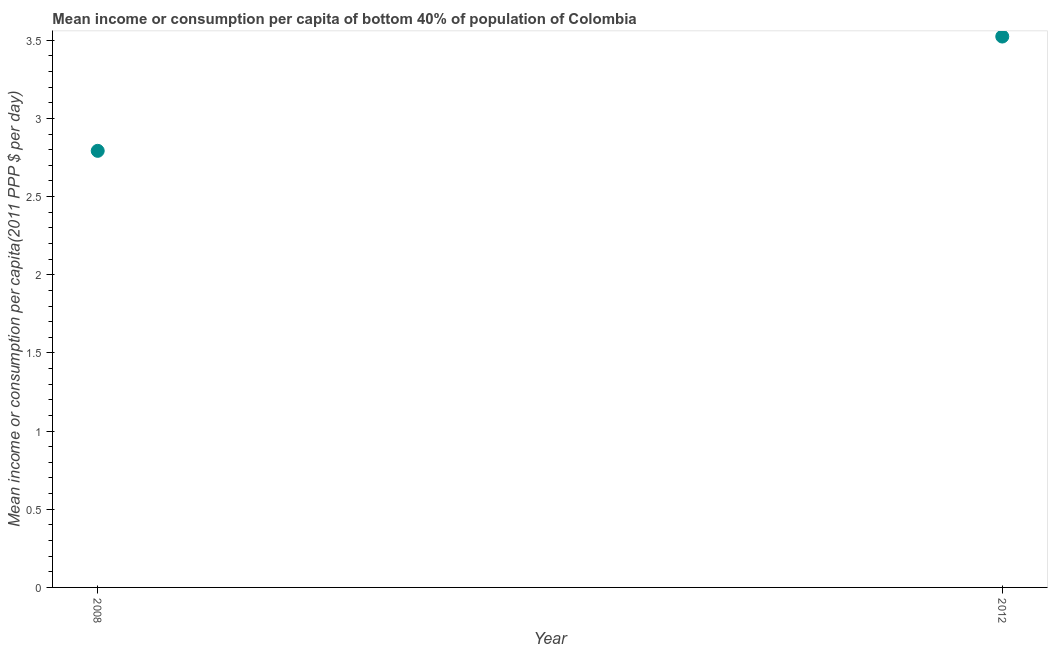What is the mean income or consumption in 2008?
Keep it short and to the point. 2.79. Across all years, what is the maximum mean income or consumption?
Make the answer very short. 3.52. Across all years, what is the minimum mean income or consumption?
Your response must be concise. 2.79. In which year was the mean income or consumption minimum?
Give a very brief answer. 2008. What is the sum of the mean income or consumption?
Your response must be concise. 6.32. What is the difference between the mean income or consumption in 2008 and 2012?
Your answer should be very brief. -0.73. What is the average mean income or consumption per year?
Provide a short and direct response. 3.16. What is the median mean income or consumption?
Keep it short and to the point. 3.16. In how many years, is the mean income or consumption greater than 3.3 $?
Provide a succinct answer. 1. What is the ratio of the mean income or consumption in 2008 to that in 2012?
Ensure brevity in your answer.  0.79. Is the mean income or consumption in 2008 less than that in 2012?
Your answer should be very brief. Yes. Does the mean income or consumption monotonically increase over the years?
Provide a short and direct response. Yes. Are the values on the major ticks of Y-axis written in scientific E-notation?
Offer a terse response. No. What is the title of the graph?
Make the answer very short. Mean income or consumption per capita of bottom 40% of population of Colombia. What is the label or title of the X-axis?
Your answer should be compact. Year. What is the label or title of the Y-axis?
Ensure brevity in your answer.  Mean income or consumption per capita(2011 PPP $ per day). What is the Mean income or consumption per capita(2011 PPP $ per day) in 2008?
Your answer should be compact. 2.79. What is the Mean income or consumption per capita(2011 PPP $ per day) in 2012?
Your answer should be compact. 3.52. What is the difference between the Mean income or consumption per capita(2011 PPP $ per day) in 2008 and 2012?
Your response must be concise. -0.73. What is the ratio of the Mean income or consumption per capita(2011 PPP $ per day) in 2008 to that in 2012?
Offer a terse response. 0.79. 